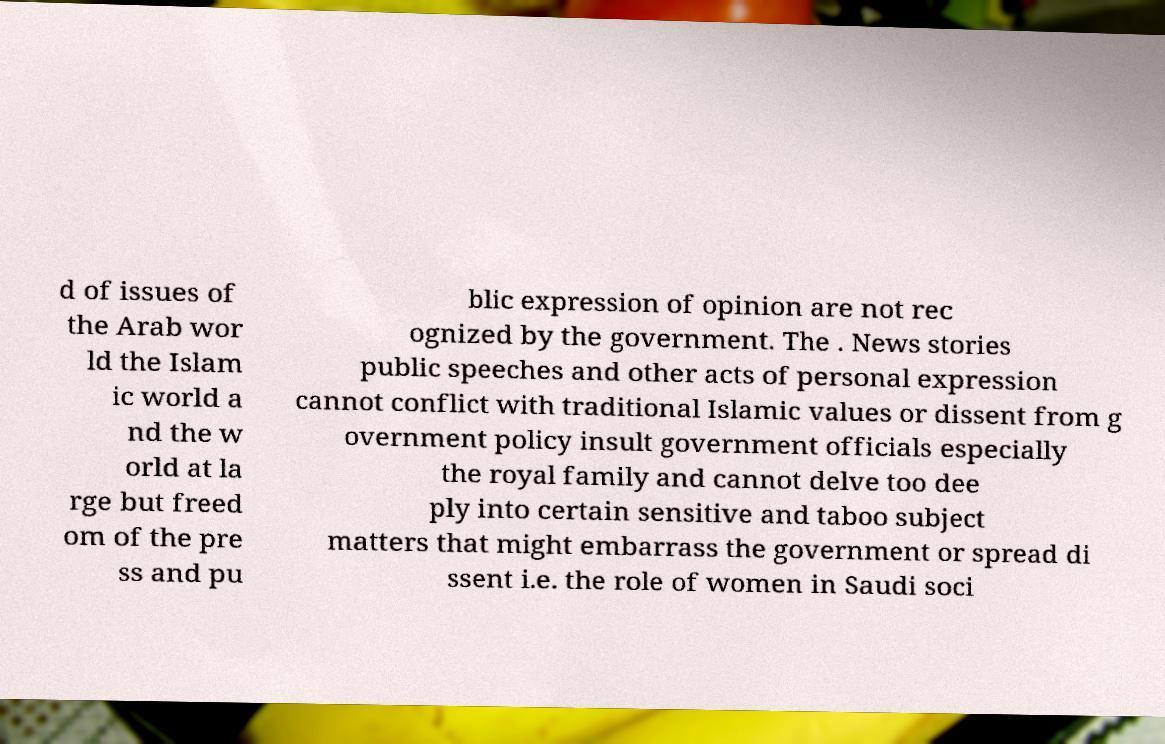Can you accurately transcribe the text from the provided image for me? d of issues of the Arab wor ld the Islam ic world a nd the w orld at la rge but freed om of the pre ss and pu blic expression of opinion are not rec ognized by the government. The . News stories public speeches and other acts of personal expression cannot conflict with traditional Islamic values or dissent from g overnment policy insult government officials especially the royal family and cannot delve too dee ply into certain sensitive and taboo subject matters that might embarrass the government or spread di ssent i.e. the role of women in Saudi soci 